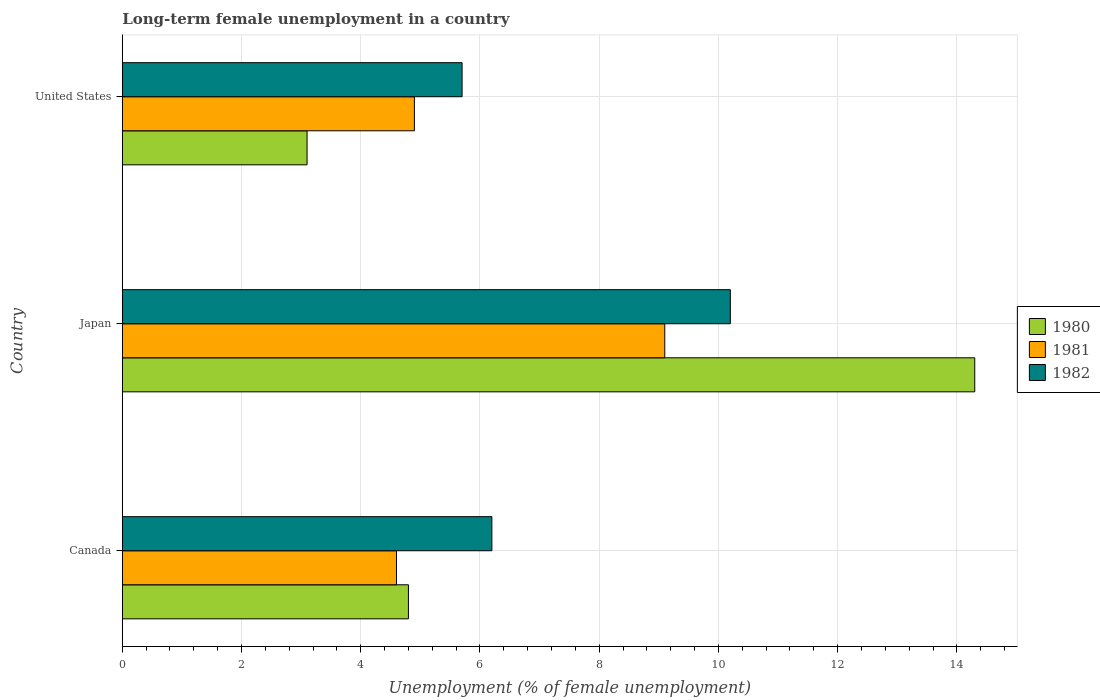How many groups of bars are there?
Your answer should be compact. 3. Are the number of bars per tick equal to the number of legend labels?
Make the answer very short. Yes. How many bars are there on the 3rd tick from the top?
Your response must be concise. 3. How many bars are there on the 3rd tick from the bottom?
Your response must be concise. 3. In how many cases, is the number of bars for a given country not equal to the number of legend labels?
Offer a very short reply. 0. What is the percentage of long-term unemployed female population in 1981 in United States?
Provide a short and direct response. 4.9. Across all countries, what is the maximum percentage of long-term unemployed female population in 1982?
Your answer should be very brief. 10.2. Across all countries, what is the minimum percentage of long-term unemployed female population in 1982?
Offer a terse response. 5.7. What is the total percentage of long-term unemployed female population in 1982 in the graph?
Ensure brevity in your answer.  22.1. What is the difference between the percentage of long-term unemployed female population in 1981 in Canada and that in United States?
Your answer should be compact. -0.3. What is the difference between the percentage of long-term unemployed female population in 1981 in Canada and the percentage of long-term unemployed female population in 1982 in United States?
Keep it short and to the point. -1.1. What is the average percentage of long-term unemployed female population in 1982 per country?
Ensure brevity in your answer.  7.37. What is the difference between the percentage of long-term unemployed female population in 1982 and percentage of long-term unemployed female population in 1981 in Canada?
Give a very brief answer. 1.6. In how many countries, is the percentage of long-term unemployed female population in 1980 greater than 12 %?
Your answer should be very brief. 1. What is the ratio of the percentage of long-term unemployed female population in 1981 in Japan to that in United States?
Keep it short and to the point. 1.86. What is the difference between the highest and the second highest percentage of long-term unemployed female population in 1982?
Your response must be concise. 4. What is the difference between the highest and the lowest percentage of long-term unemployed female population in 1982?
Provide a short and direct response. 4.5. Is it the case that in every country, the sum of the percentage of long-term unemployed female population in 1980 and percentage of long-term unemployed female population in 1981 is greater than the percentage of long-term unemployed female population in 1982?
Offer a very short reply. Yes. How many bars are there?
Your answer should be very brief. 9. Are the values on the major ticks of X-axis written in scientific E-notation?
Your answer should be compact. No. Does the graph contain any zero values?
Make the answer very short. No. Does the graph contain grids?
Your answer should be very brief. Yes. Where does the legend appear in the graph?
Your answer should be very brief. Center right. How many legend labels are there?
Provide a succinct answer. 3. How are the legend labels stacked?
Provide a succinct answer. Vertical. What is the title of the graph?
Make the answer very short. Long-term female unemployment in a country. What is the label or title of the X-axis?
Provide a succinct answer. Unemployment (% of female unemployment). What is the label or title of the Y-axis?
Provide a short and direct response. Country. What is the Unemployment (% of female unemployment) of 1980 in Canada?
Your response must be concise. 4.8. What is the Unemployment (% of female unemployment) in 1981 in Canada?
Offer a very short reply. 4.6. What is the Unemployment (% of female unemployment) of 1982 in Canada?
Your answer should be very brief. 6.2. What is the Unemployment (% of female unemployment) in 1980 in Japan?
Provide a short and direct response. 14.3. What is the Unemployment (% of female unemployment) of 1981 in Japan?
Provide a succinct answer. 9.1. What is the Unemployment (% of female unemployment) of 1982 in Japan?
Offer a very short reply. 10.2. What is the Unemployment (% of female unemployment) in 1980 in United States?
Your response must be concise. 3.1. What is the Unemployment (% of female unemployment) of 1981 in United States?
Provide a short and direct response. 4.9. What is the Unemployment (% of female unemployment) of 1982 in United States?
Offer a very short reply. 5.7. Across all countries, what is the maximum Unemployment (% of female unemployment) of 1980?
Ensure brevity in your answer.  14.3. Across all countries, what is the maximum Unemployment (% of female unemployment) of 1981?
Keep it short and to the point. 9.1. Across all countries, what is the maximum Unemployment (% of female unemployment) in 1982?
Offer a terse response. 10.2. Across all countries, what is the minimum Unemployment (% of female unemployment) of 1980?
Your answer should be compact. 3.1. Across all countries, what is the minimum Unemployment (% of female unemployment) in 1981?
Give a very brief answer. 4.6. Across all countries, what is the minimum Unemployment (% of female unemployment) in 1982?
Your answer should be very brief. 5.7. What is the total Unemployment (% of female unemployment) in 1982 in the graph?
Your answer should be very brief. 22.1. What is the difference between the Unemployment (% of female unemployment) of 1980 in Canada and that in Japan?
Your response must be concise. -9.5. What is the difference between the Unemployment (% of female unemployment) in 1981 in Canada and that in Japan?
Provide a short and direct response. -4.5. What is the difference between the Unemployment (% of female unemployment) in 1981 in Canada and that in United States?
Your answer should be very brief. -0.3. What is the difference between the Unemployment (% of female unemployment) in 1982 in Japan and that in United States?
Give a very brief answer. 4.5. What is the difference between the Unemployment (% of female unemployment) of 1980 in Canada and the Unemployment (% of female unemployment) of 1981 in Japan?
Ensure brevity in your answer.  -4.3. What is the difference between the Unemployment (% of female unemployment) of 1981 in Canada and the Unemployment (% of female unemployment) of 1982 in United States?
Provide a short and direct response. -1.1. What is the difference between the Unemployment (% of female unemployment) of 1981 in Japan and the Unemployment (% of female unemployment) of 1982 in United States?
Provide a short and direct response. 3.4. What is the average Unemployment (% of female unemployment) of 1980 per country?
Give a very brief answer. 7.4. What is the average Unemployment (% of female unemployment) of 1981 per country?
Keep it short and to the point. 6.2. What is the average Unemployment (% of female unemployment) in 1982 per country?
Make the answer very short. 7.37. What is the difference between the Unemployment (% of female unemployment) in 1980 and Unemployment (% of female unemployment) in 1981 in Japan?
Your answer should be very brief. 5.2. What is the difference between the Unemployment (% of female unemployment) of 1980 and Unemployment (% of female unemployment) of 1981 in United States?
Keep it short and to the point. -1.8. What is the difference between the Unemployment (% of female unemployment) in 1981 and Unemployment (% of female unemployment) in 1982 in United States?
Provide a succinct answer. -0.8. What is the ratio of the Unemployment (% of female unemployment) of 1980 in Canada to that in Japan?
Ensure brevity in your answer.  0.34. What is the ratio of the Unemployment (% of female unemployment) of 1981 in Canada to that in Japan?
Provide a succinct answer. 0.51. What is the ratio of the Unemployment (% of female unemployment) in 1982 in Canada to that in Japan?
Offer a very short reply. 0.61. What is the ratio of the Unemployment (% of female unemployment) of 1980 in Canada to that in United States?
Keep it short and to the point. 1.55. What is the ratio of the Unemployment (% of female unemployment) of 1981 in Canada to that in United States?
Your answer should be compact. 0.94. What is the ratio of the Unemployment (% of female unemployment) of 1982 in Canada to that in United States?
Offer a terse response. 1.09. What is the ratio of the Unemployment (% of female unemployment) of 1980 in Japan to that in United States?
Provide a succinct answer. 4.61. What is the ratio of the Unemployment (% of female unemployment) of 1981 in Japan to that in United States?
Your response must be concise. 1.86. What is the ratio of the Unemployment (% of female unemployment) of 1982 in Japan to that in United States?
Offer a very short reply. 1.79. What is the difference between the highest and the second highest Unemployment (% of female unemployment) of 1980?
Make the answer very short. 9.5. What is the difference between the highest and the lowest Unemployment (% of female unemployment) in 1980?
Keep it short and to the point. 11.2. What is the difference between the highest and the lowest Unemployment (% of female unemployment) of 1981?
Make the answer very short. 4.5. What is the difference between the highest and the lowest Unemployment (% of female unemployment) in 1982?
Provide a short and direct response. 4.5. 